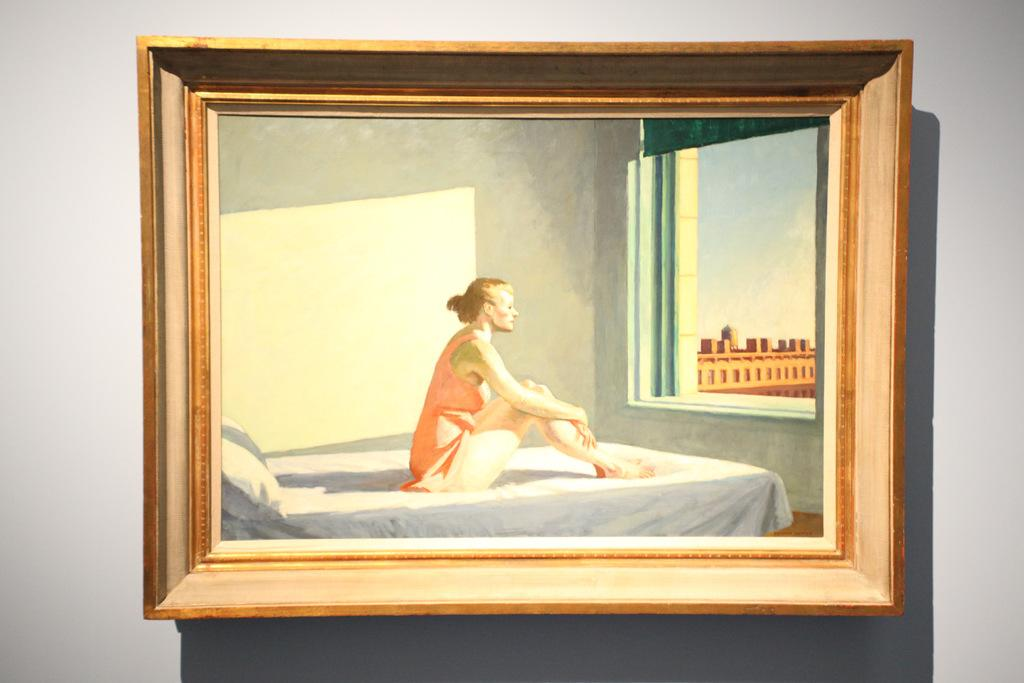What is hanging on the wall in the image? There is a photo frame on the wall. What is the woman doing in the image? The woman is sitting on a cot. What is the woman looking at in the image? The woman is looking out the window. How many oranges are on the table in the image? There is no table or oranges present in the image. What statement does the woman make in the image? There is no dialogue or statement made by the woman in the image. 